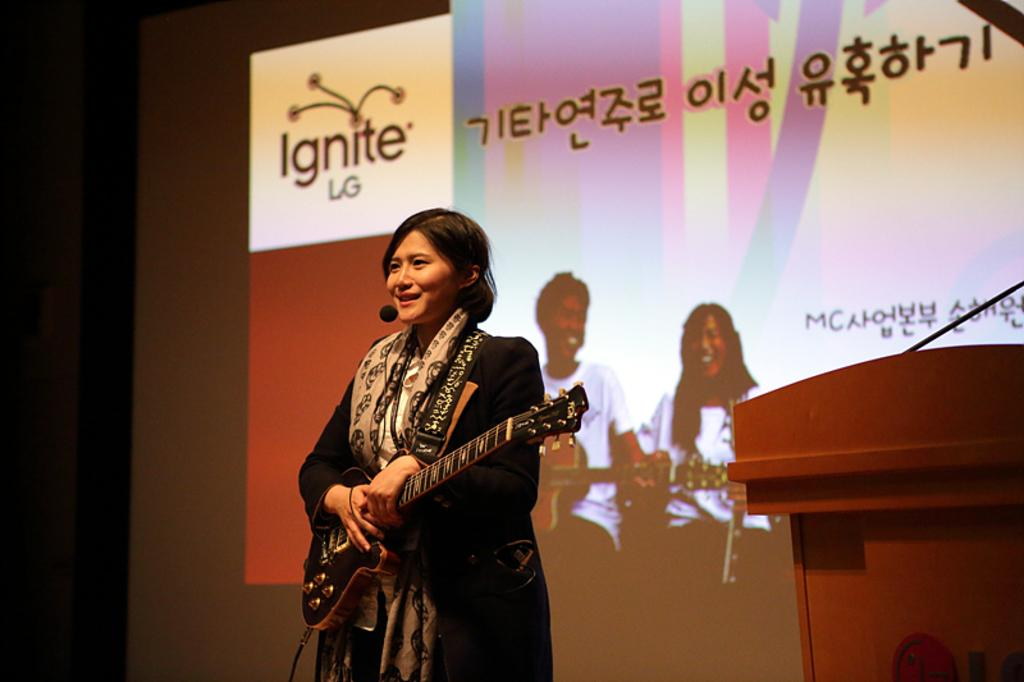Who is present in the image? There is a woman in the image. What is the woman doing in the image? The woman is smiling and holding a guitar. What can be seen behind the woman in the image? There is a Background Eraser projector screen in the image. What type of soup is being served on the guitar in the image? There is no soup present in the image, and the guitar is not being used to serve any food. 